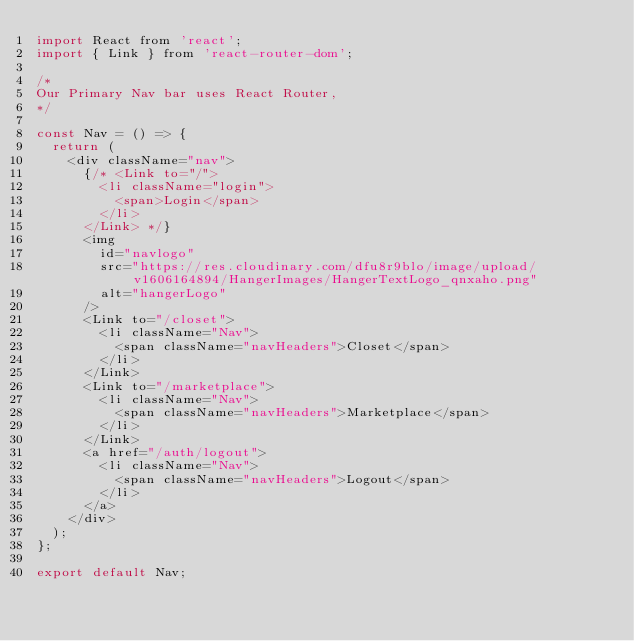<code> <loc_0><loc_0><loc_500><loc_500><_JavaScript_>import React from 'react';
import { Link } from 'react-router-dom';

/*
Our Primary Nav bar uses React Router,
*/

const Nav = () => {
  return (
    <div className="nav">
      {/* <Link to="/">
        <li className="login">
          <span>Login</span>
        </li>
      </Link> */}
      <img
        id="navlogo"
        src="https://res.cloudinary.com/dfu8r9blo/image/upload/v1606164894/HangerImages/HangerTextLogo_qnxaho.png"
        alt="hangerLogo"
      />
      <Link to="/closet">
        <li className="Nav">
          <span className="navHeaders">Closet</span>
        </li>
      </Link>
      <Link to="/marketplace">
        <li className="Nav">
          <span className="navHeaders">Marketplace</span>
        </li>
      </Link>
      <a href="/auth/logout">
        <li className="Nav">
          <span className="navHeaders">Logout</span>
        </li>
      </a>
    </div>
  );
};

export default Nav;
</code> 